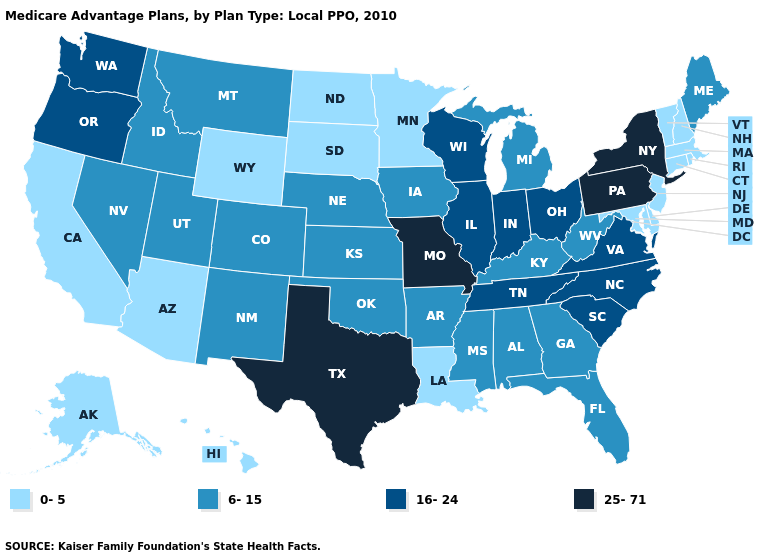Does the first symbol in the legend represent the smallest category?
Short answer required. Yes. Does Wyoming have the highest value in the West?
Short answer required. No. Which states have the lowest value in the Northeast?
Keep it brief. Connecticut, Massachusetts, New Hampshire, New Jersey, Rhode Island, Vermont. What is the value of Oklahoma?
Give a very brief answer. 6-15. What is the lowest value in states that border Delaware?
Write a very short answer. 0-5. Which states have the lowest value in the Northeast?
Short answer required. Connecticut, Massachusetts, New Hampshire, New Jersey, Rhode Island, Vermont. How many symbols are there in the legend?
Write a very short answer. 4. Name the states that have a value in the range 16-24?
Short answer required. Illinois, Indiana, North Carolina, Ohio, Oregon, South Carolina, Tennessee, Virginia, Washington, Wisconsin. What is the value of Mississippi?
Answer briefly. 6-15. What is the value of New Hampshire?
Concise answer only. 0-5. Which states have the lowest value in the USA?
Be succinct. Alaska, Arizona, California, Connecticut, Delaware, Hawaii, Louisiana, Massachusetts, Maryland, Minnesota, North Dakota, New Hampshire, New Jersey, Rhode Island, South Dakota, Vermont, Wyoming. Among the states that border Missouri , which have the highest value?
Answer briefly. Illinois, Tennessee. Name the states that have a value in the range 25-71?
Concise answer only. Missouri, New York, Pennsylvania, Texas. Which states have the lowest value in the USA?
Keep it brief. Alaska, Arizona, California, Connecticut, Delaware, Hawaii, Louisiana, Massachusetts, Maryland, Minnesota, North Dakota, New Hampshire, New Jersey, Rhode Island, South Dakota, Vermont, Wyoming. Name the states that have a value in the range 25-71?
Concise answer only. Missouri, New York, Pennsylvania, Texas. 